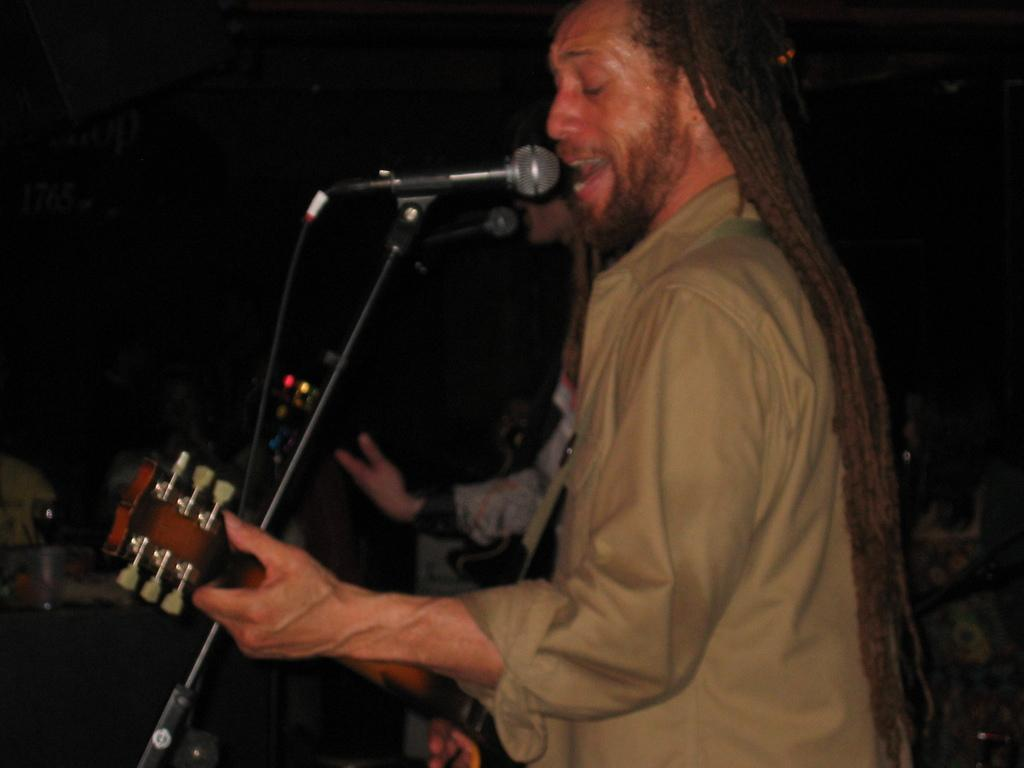What is the man in the image doing? The man is holding a guitar, playing it, and singing. What instrument is the man using in the image? The man is using a guitar in the image. How is the man's voice being amplified in the image? The man is using a microphone in the image. Can you describe the background of the image? The background of the image is dark. Are there any other people visible in the image? Yes, there is another person in the background. What type of chalk is the man using to draw on the boat in the image? There is no chalk or boat present in the image; it features a man playing the guitar, singing, and using a microphone. 